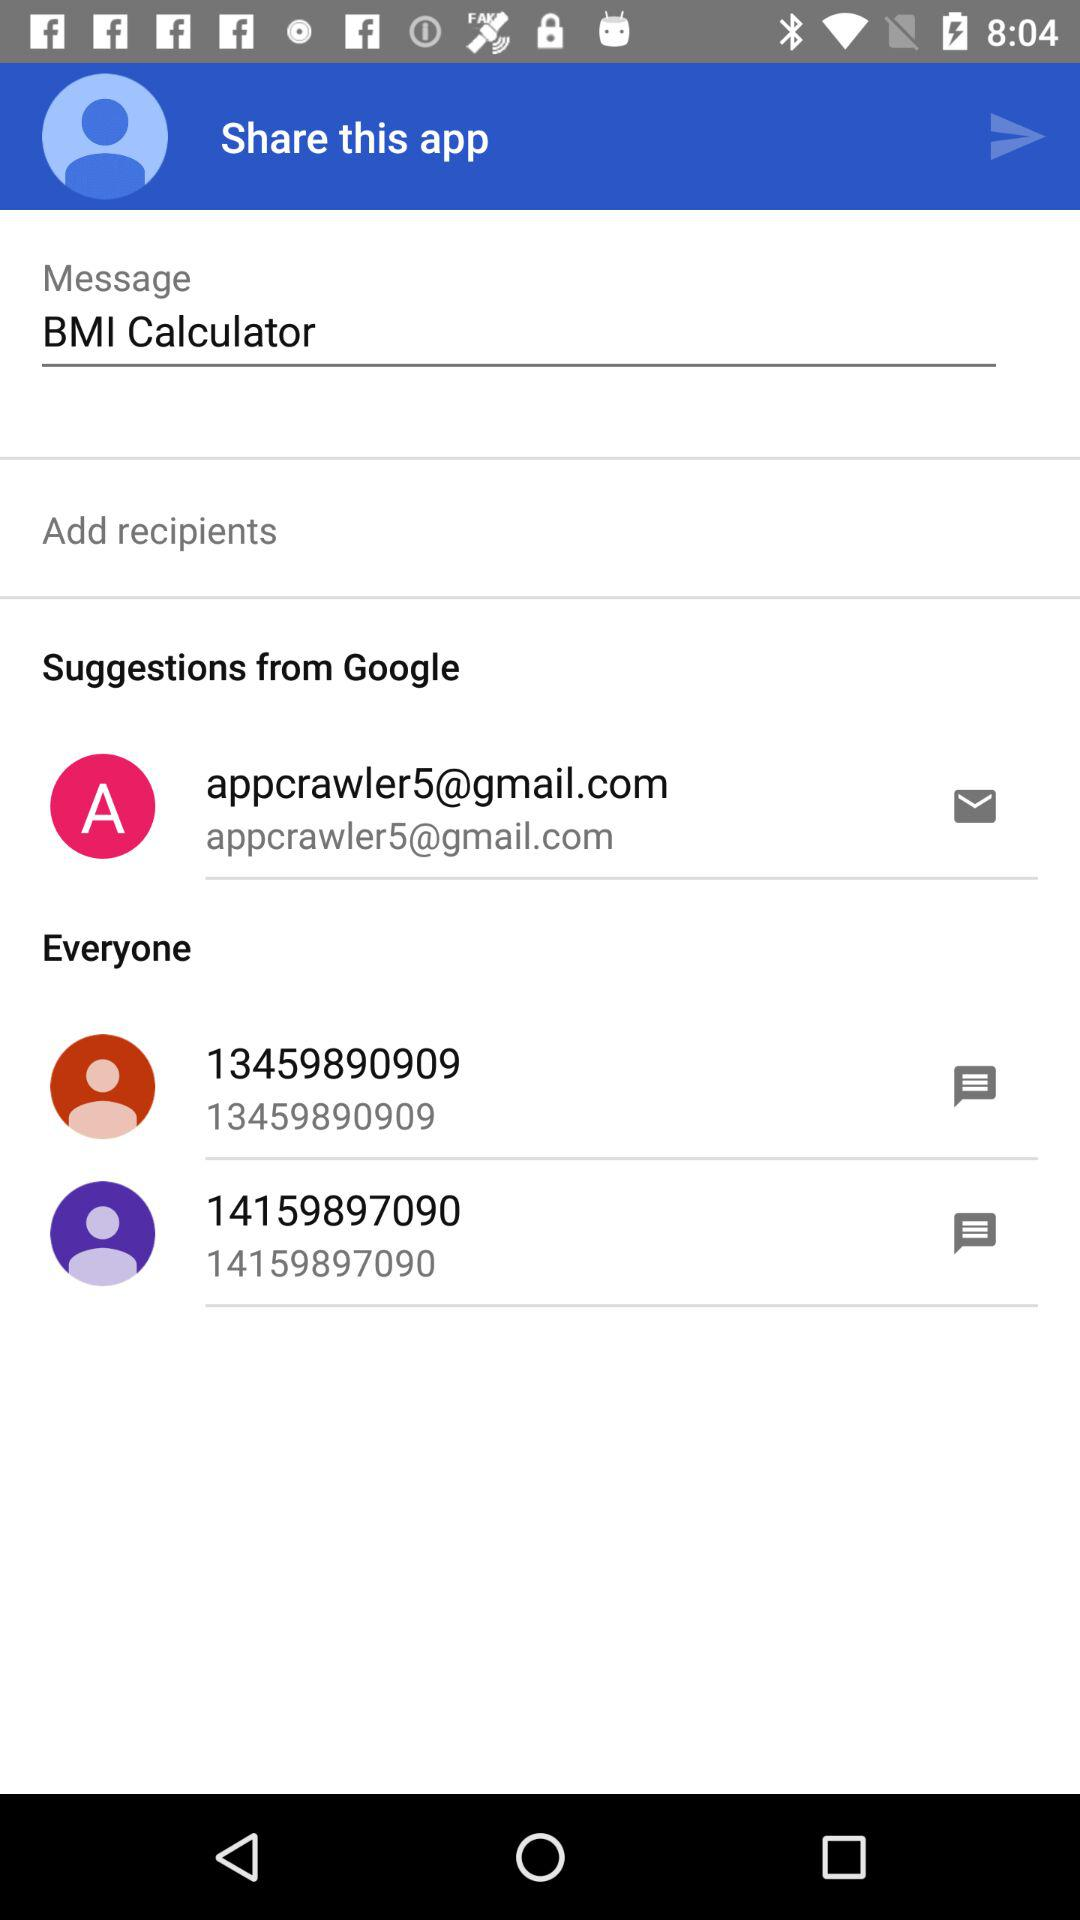What is the mobile number starting with 134? The mobile number is 13459890909. 